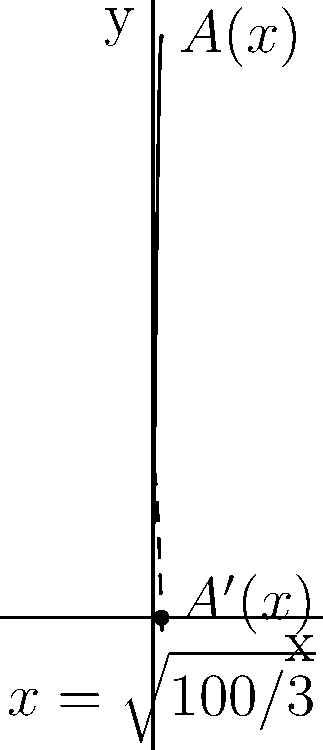A rectangular beam has a cross-sectional area $A(x) = 100x - x^3$ square inches, where $x$ is the width in inches. Find the width that maximizes the cross-sectional area, and determine the maximum area. How does this relate to the beam's strength? To find the maximum cross-sectional area, we need to follow these steps:

1) First, we find the derivative of $A(x)$:
   $$A'(x) = 100 - 3x^2$$

2) To find the critical points, we set $A'(x) = 0$:
   $$100 - 3x^2 = 0$$
   $$3x^2 = 100$$
   $$x^2 = \frac{100}{3}$$
   $$x = \pm\sqrt{\frac{100}{3}}$$

3) Since width can't be negative, we only consider the positive solution:
   $$x = \sqrt{\frac{100}{3}} \approx 5.77 \text{ inches}$$

4) To confirm this is a maximum, we can check the second derivative:
   $$A''(x) = -6x$$
   At $x = \sqrt{\frac{100}{3}}$, $A''(x) < 0$, confirming a maximum.

5) The maximum area is found by plugging this x-value back into $A(x)$:
   $$A(\sqrt{\frac{100}{3}}) = 100\sqrt{\frac{100}{3}} - (\sqrt{\frac{100}{3}})^3$$
   $$= 100\sqrt{\frac{100}{3}} - \frac{1000}{\sqrt{3}}$$
   $$\approx 192.45 \text{ square inches}$$

This optimal cross-section maximizes the beam's ability to resist bending and torsion, directly correlating with its strength. The balance between width and depth (implied by the area function) ensures optimal material distribution for load-bearing capacity.
Answer: Width: $\sqrt{\frac{100}{3}}$ inches; Maximum area: $100\sqrt{\frac{100}{3}} - \frac{1000}{\sqrt{3}}$ square inches 